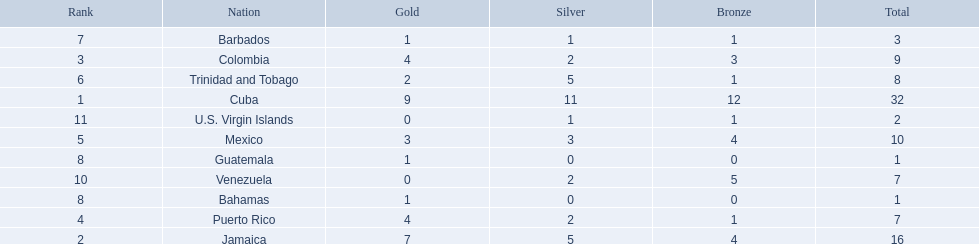Which nations played in the games? Cuba, Jamaica, Colombia, Puerto Rico, Mexico, Trinidad and Tobago, Barbados, Guatemala, Bahamas, Venezuela, U.S. Virgin Islands. How many silver medals did they win? 11, 5, 2, 2, 3, 5, 1, 0, 0, 2, 1. Which team won the most silver? Cuba. 